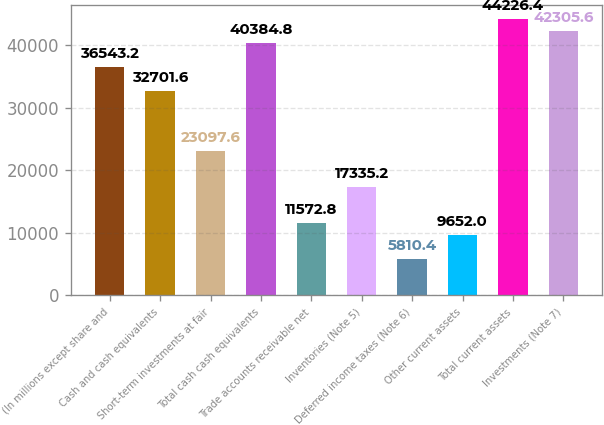Convert chart to OTSL. <chart><loc_0><loc_0><loc_500><loc_500><bar_chart><fcel>(In millions except share and<fcel>Cash and cash equivalents<fcel>Short-term investments at fair<fcel>Total cash cash equivalents<fcel>Trade accounts receivable net<fcel>Inventories (Note 5)<fcel>Deferred income taxes (Note 6)<fcel>Other current assets<fcel>Total current assets<fcel>Investments (Note 7)<nl><fcel>36543.2<fcel>32701.6<fcel>23097.6<fcel>40384.8<fcel>11572.8<fcel>17335.2<fcel>5810.4<fcel>9652<fcel>44226.4<fcel>42305.6<nl></chart> 